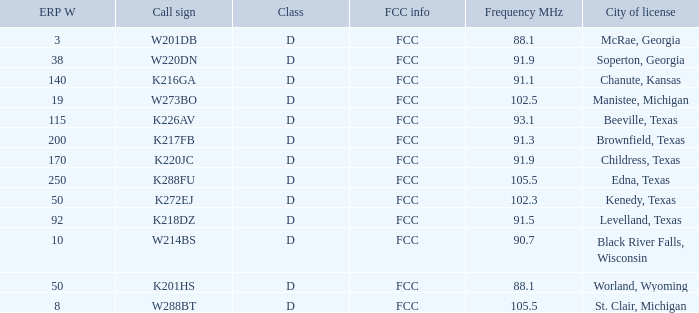What is Call Sign, when City of License is Brownfield, Texas? K217FB. Parse the full table. {'header': ['ERP W', 'Call sign', 'Class', 'FCC info', 'Frequency MHz', 'City of license'], 'rows': [['3', 'W201DB', 'D', 'FCC', '88.1', 'McRae, Georgia'], ['38', 'W220DN', 'D', 'FCC', '91.9', 'Soperton, Georgia'], ['140', 'K216GA', 'D', 'FCC', '91.1', 'Chanute, Kansas'], ['19', 'W273BO', 'D', 'FCC', '102.5', 'Manistee, Michigan'], ['115', 'K226AV', 'D', 'FCC', '93.1', 'Beeville, Texas'], ['200', 'K217FB', 'D', 'FCC', '91.3', 'Brownfield, Texas'], ['170', 'K220JC', 'D', 'FCC', '91.9', 'Childress, Texas'], ['250', 'K288FU', 'D', 'FCC', '105.5', 'Edna, Texas'], ['50', 'K272EJ', 'D', 'FCC', '102.3', 'Kenedy, Texas'], ['92', 'K218DZ', 'D', 'FCC', '91.5', 'Levelland, Texas'], ['10', 'W214BS', 'D', 'FCC', '90.7', 'Black River Falls, Wisconsin'], ['50', 'K201HS', 'D', 'FCC', '88.1', 'Worland, Wyoming'], ['8', 'W288BT', 'D', 'FCC', '105.5', 'St. Clair, Michigan']]} 